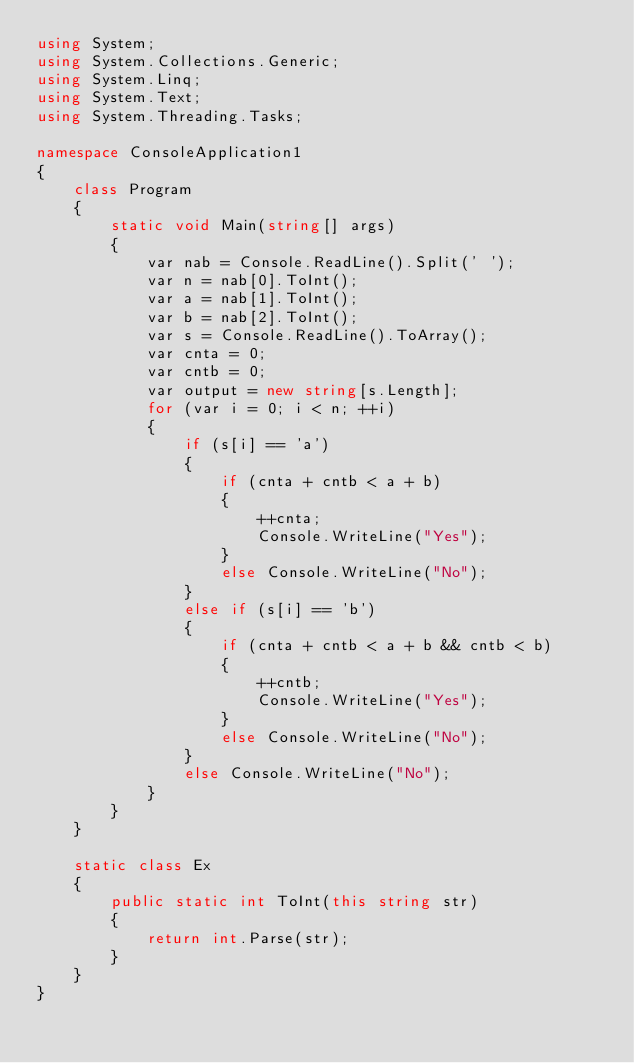<code> <loc_0><loc_0><loc_500><loc_500><_C#_>using System;
using System.Collections.Generic;
using System.Linq;
using System.Text;
using System.Threading.Tasks;

namespace ConsoleApplication1
{
    class Program
    {
        static void Main(string[] args)
        {
            var nab = Console.ReadLine().Split(' ');
            var n = nab[0].ToInt();
            var a = nab[1].ToInt();
            var b = nab[2].ToInt();
            var s = Console.ReadLine().ToArray();
            var cnta = 0;
            var cntb = 0;
            var output = new string[s.Length];
            for (var i = 0; i < n; ++i)
            {
                if (s[i] == 'a')
                {
                    if (cnta + cntb < a + b)
                    {
                        ++cnta;
                        Console.WriteLine("Yes");
                    }
                    else Console.WriteLine("No");
                }
                else if (s[i] == 'b')
                {
                    if (cnta + cntb < a + b && cntb < b)
                    {
                        ++cntb;
                        Console.WriteLine("Yes");
                    }
                    else Console.WriteLine("No");
                }
                else Console.WriteLine("No");
            }
        }
    }

    static class Ex
    {
        public static int ToInt(this string str)
        {
            return int.Parse(str);
        }
    }
}
</code> 